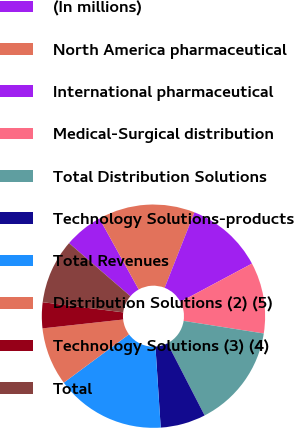Convert chart. <chart><loc_0><loc_0><loc_500><loc_500><pie_chart><fcel>(In millions)<fcel>North America pharmaceutical<fcel>International pharmaceutical<fcel>Medical-Surgical distribution<fcel>Total Distribution Solutions<fcel>Technology Solutions-products<fcel>Total Revenues<fcel>Distribution Solutions (2) (5)<fcel>Technology Solutions (3) (4)<fcel>Total<nl><fcel>5.61%<fcel>14.02%<fcel>11.21%<fcel>10.28%<fcel>14.95%<fcel>6.54%<fcel>15.88%<fcel>8.41%<fcel>3.74%<fcel>9.35%<nl></chart> 